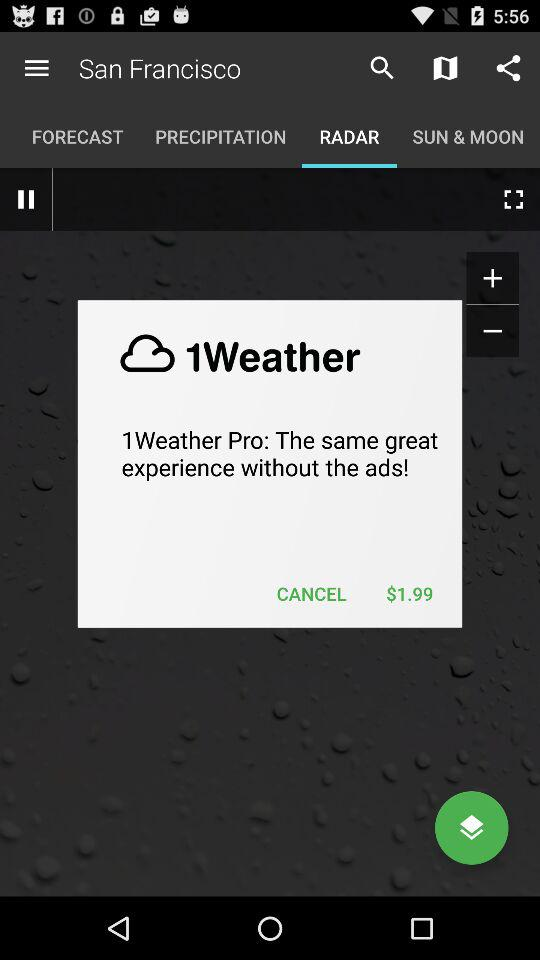How much $ is displayed? There is $1.99 displayed. 